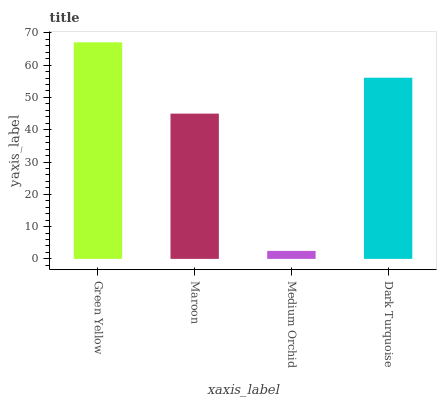Is Medium Orchid the minimum?
Answer yes or no. Yes. Is Green Yellow the maximum?
Answer yes or no. Yes. Is Maroon the minimum?
Answer yes or no. No. Is Maroon the maximum?
Answer yes or no. No. Is Green Yellow greater than Maroon?
Answer yes or no. Yes. Is Maroon less than Green Yellow?
Answer yes or no. Yes. Is Maroon greater than Green Yellow?
Answer yes or no. No. Is Green Yellow less than Maroon?
Answer yes or no. No. Is Dark Turquoise the high median?
Answer yes or no. Yes. Is Maroon the low median?
Answer yes or no. Yes. Is Maroon the high median?
Answer yes or no. No. Is Green Yellow the low median?
Answer yes or no. No. 